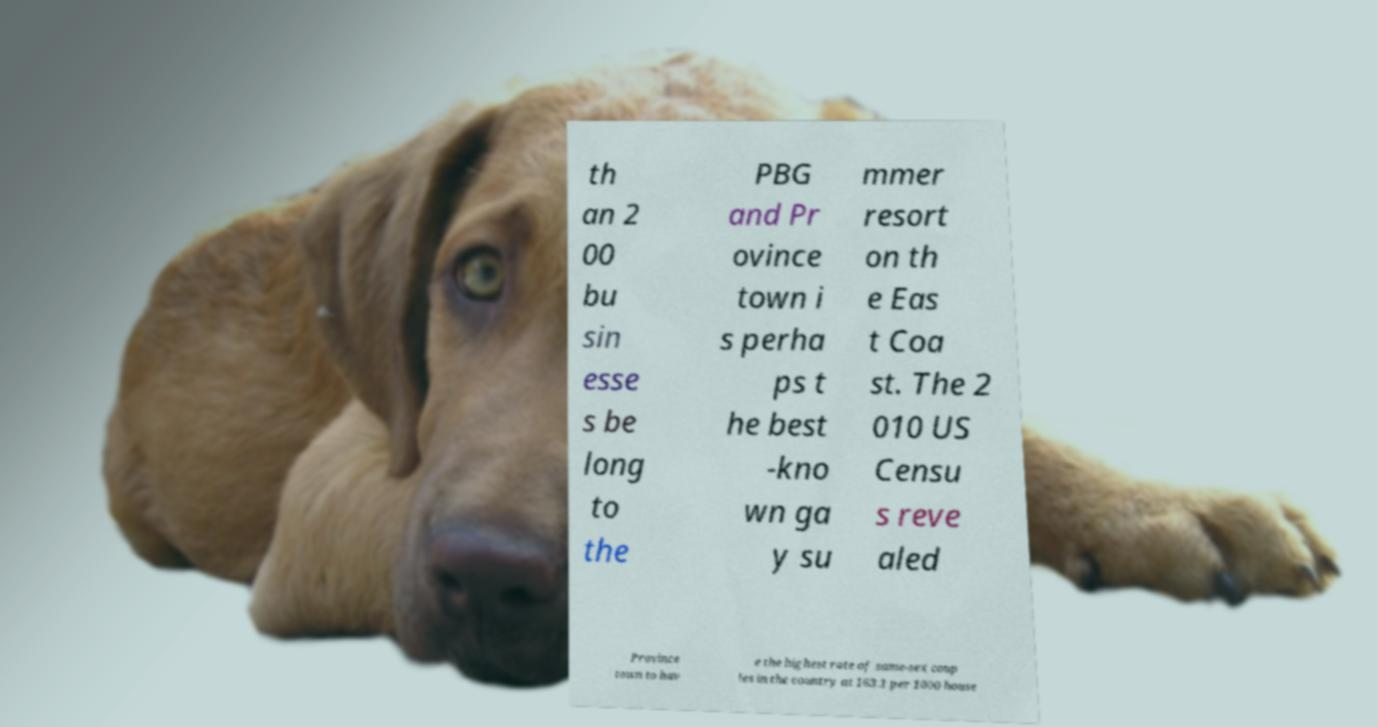What messages or text are displayed in this image? I need them in a readable, typed format. th an 2 00 bu sin esse s be long to the PBG and Pr ovince town i s perha ps t he best -kno wn ga y su mmer resort on th e Eas t Coa st. The 2 010 US Censu s reve aled Province town to hav e the highest rate of same-sex coup les in the country at 163.1 per 1000 house 